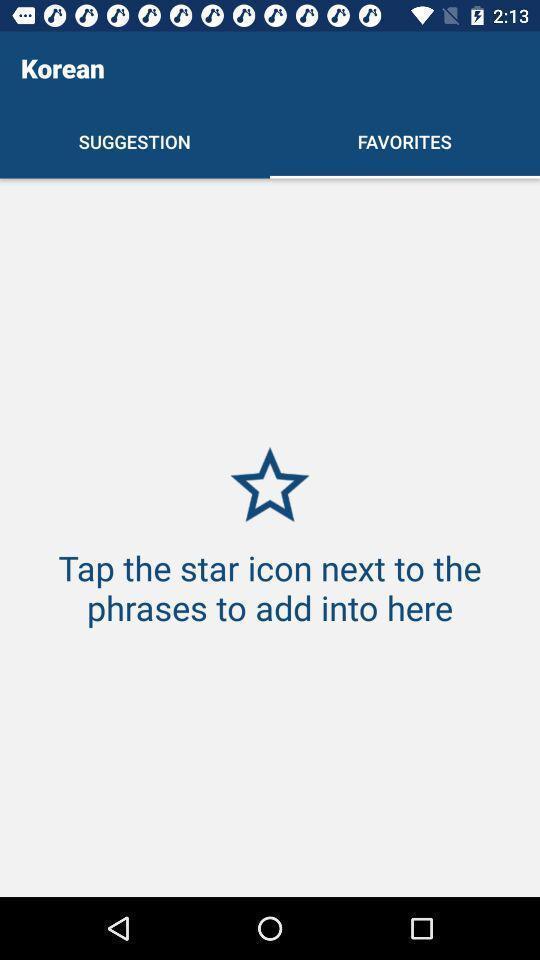Explain the elements present in this screenshot. Screen displaying page of an language learning application. 